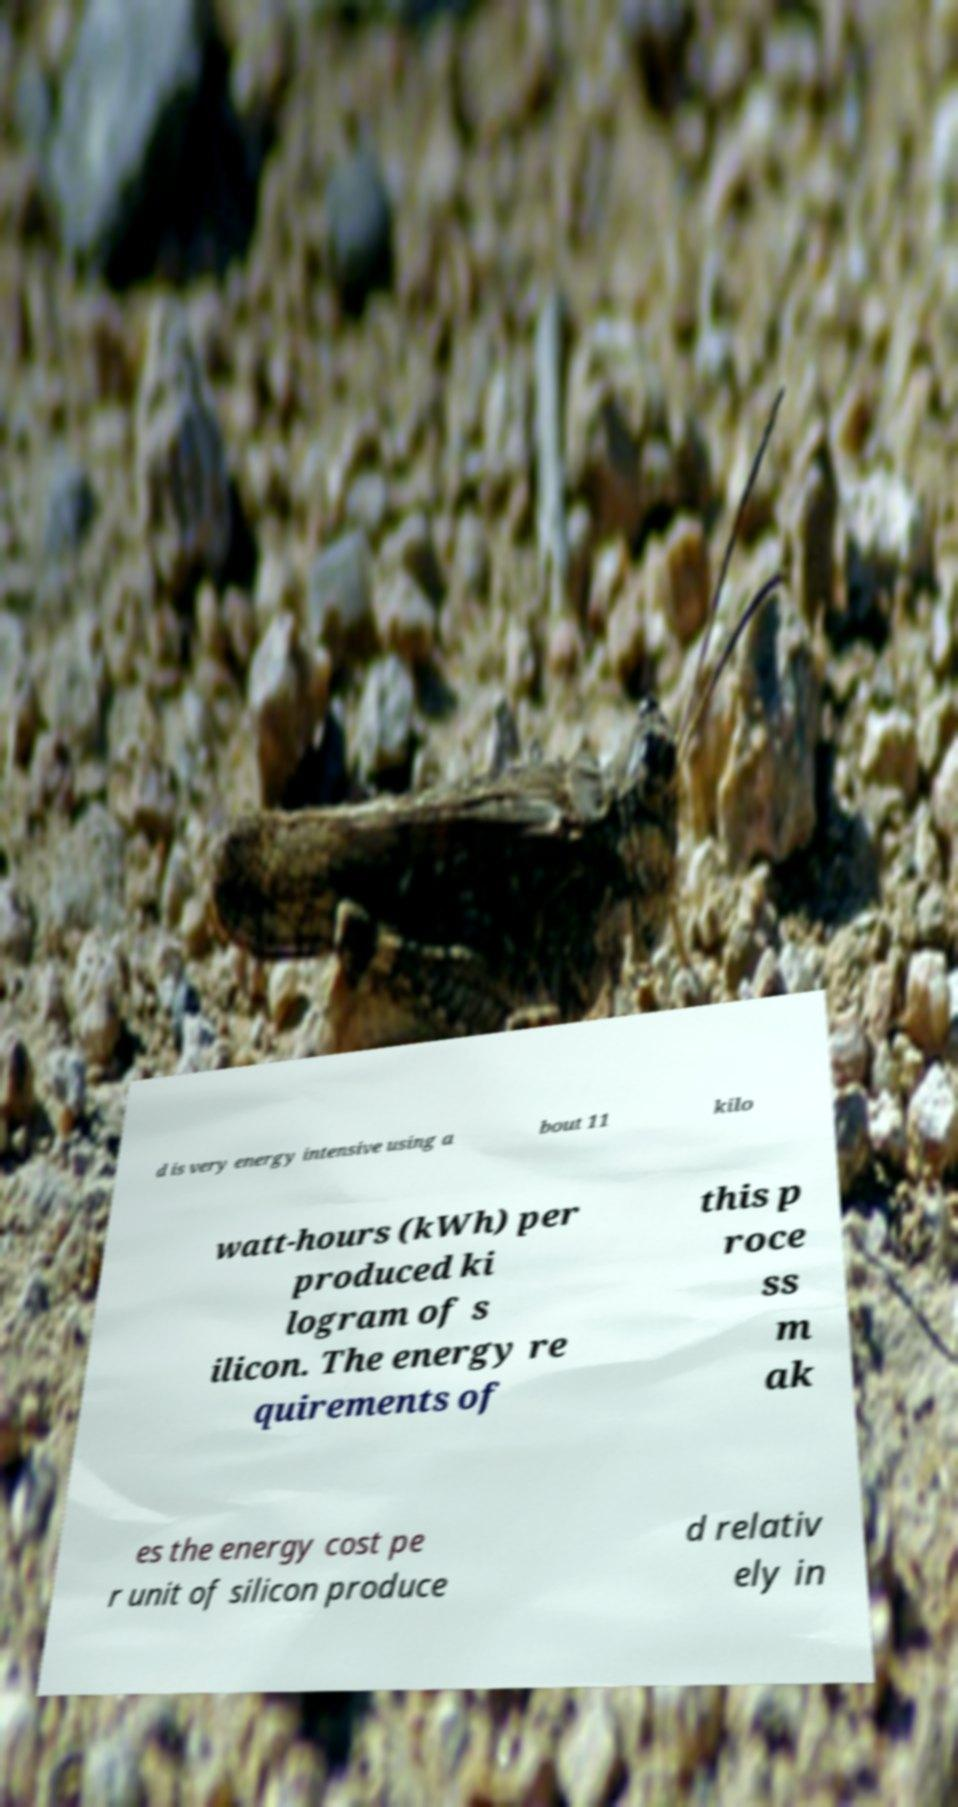What messages or text are displayed in this image? I need them in a readable, typed format. d is very energy intensive using a bout 11 kilo watt-hours (kWh) per produced ki logram of s ilicon. The energy re quirements of this p roce ss m ak es the energy cost pe r unit of silicon produce d relativ ely in 